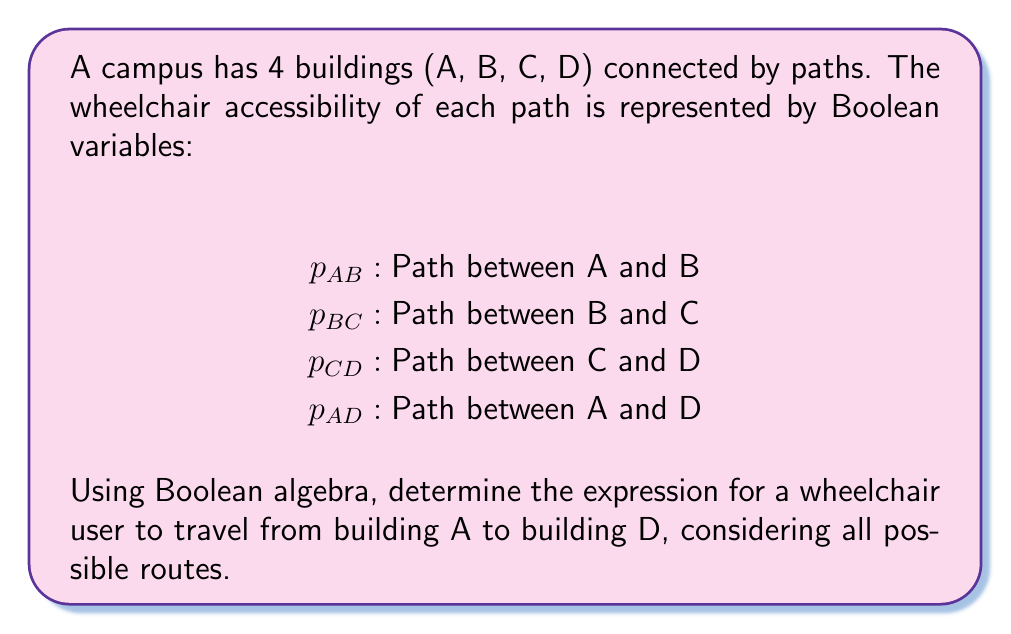Can you solve this math problem? Let's approach this step-by-step:

1) There are two main routes from A to D:
   a) Directly from A to D
   b) Through B and C

2) The direct route is simply represented by $p_{AD}$

3) The route through B and C can be broken down as:
   A to B AND B to C AND C to D
   This is represented in Boolean algebra as: $p_{AB} \cdot p_{BC} \cdot p_{CD}$

4) Since we want either the direct route OR the route through B and C, we use the OR operation (+) in Boolean algebra:

   $p_{AD} + (p_{AB} \cdot p_{BC} \cdot p_{CD})$

5) This expression represents all possible routes from A to D that are accessible for a wheelchair user.

6) We can't simplify this expression further without additional information about the specific values of these variables.
Answer: $p_{AD} + (p_{AB} \cdot p_{BC} \cdot p_{CD})$ 